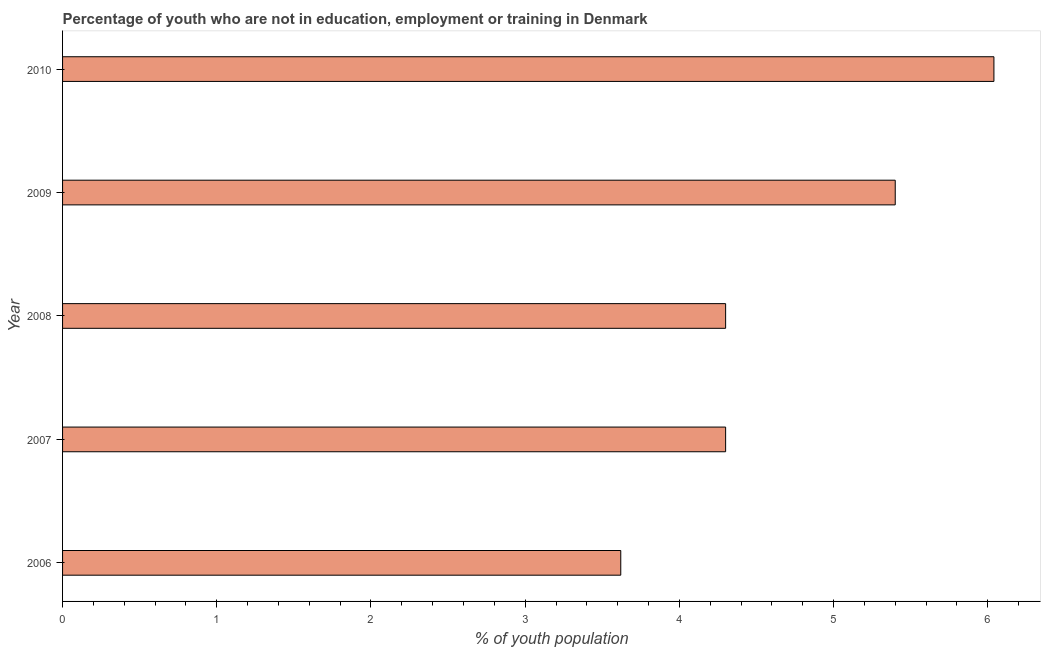Does the graph contain any zero values?
Make the answer very short. No. Does the graph contain grids?
Ensure brevity in your answer.  No. What is the title of the graph?
Provide a succinct answer. Percentage of youth who are not in education, employment or training in Denmark. What is the label or title of the X-axis?
Provide a short and direct response. % of youth population. What is the unemployed youth population in 2007?
Your answer should be very brief. 4.3. Across all years, what is the maximum unemployed youth population?
Provide a succinct answer. 6.04. Across all years, what is the minimum unemployed youth population?
Your response must be concise. 3.62. What is the sum of the unemployed youth population?
Offer a terse response. 23.66. What is the difference between the unemployed youth population in 2006 and 2008?
Your response must be concise. -0.68. What is the average unemployed youth population per year?
Ensure brevity in your answer.  4.73. What is the median unemployed youth population?
Offer a very short reply. 4.3. In how many years, is the unemployed youth population greater than 0.4 %?
Your answer should be very brief. 5. Do a majority of the years between 2010 and 2007 (inclusive) have unemployed youth population greater than 4.6 %?
Offer a terse response. Yes. What is the ratio of the unemployed youth population in 2008 to that in 2009?
Your answer should be compact. 0.8. Is the unemployed youth population in 2006 less than that in 2010?
Give a very brief answer. Yes. Is the difference between the unemployed youth population in 2009 and 2010 greater than the difference between any two years?
Offer a terse response. No. What is the difference between the highest and the second highest unemployed youth population?
Give a very brief answer. 0.64. Is the sum of the unemployed youth population in 2008 and 2010 greater than the maximum unemployed youth population across all years?
Your answer should be compact. Yes. What is the difference between the highest and the lowest unemployed youth population?
Make the answer very short. 2.42. Are all the bars in the graph horizontal?
Your answer should be very brief. Yes. What is the difference between two consecutive major ticks on the X-axis?
Offer a terse response. 1. What is the % of youth population in 2006?
Give a very brief answer. 3.62. What is the % of youth population in 2007?
Keep it short and to the point. 4.3. What is the % of youth population in 2008?
Ensure brevity in your answer.  4.3. What is the % of youth population of 2009?
Offer a terse response. 5.4. What is the % of youth population in 2010?
Keep it short and to the point. 6.04. What is the difference between the % of youth population in 2006 and 2007?
Ensure brevity in your answer.  -0.68. What is the difference between the % of youth population in 2006 and 2008?
Offer a very short reply. -0.68. What is the difference between the % of youth population in 2006 and 2009?
Your answer should be very brief. -1.78. What is the difference between the % of youth population in 2006 and 2010?
Your answer should be compact. -2.42. What is the difference between the % of youth population in 2007 and 2010?
Your answer should be compact. -1.74. What is the difference between the % of youth population in 2008 and 2010?
Your response must be concise. -1.74. What is the difference between the % of youth population in 2009 and 2010?
Your answer should be compact. -0.64. What is the ratio of the % of youth population in 2006 to that in 2007?
Your answer should be compact. 0.84. What is the ratio of the % of youth population in 2006 to that in 2008?
Your response must be concise. 0.84. What is the ratio of the % of youth population in 2006 to that in 2009?
Your answer should be very brief. 0.67. What is the ratio of the % of youth population in 2006 to that in 2010?
Offer a terse response. 0.6. What is the ratio of the % of youth population in 2007 to that in 2008?
Keep it short and to the point. 1. What is the ratio of the % of youth population in 2007 to that in 2009?
Your answer should be compact. 0.8. What is the ratio of the % of youth population in 2007 to that in 2010?
Provide a short and direct response. 0.71. What is the ratio of the % of youth population in 2008 to that in 2009?
Keep it short and to the point. 0.8. What is the ratio of the % of youth population in 2008 to that in 2010?
Offer a very short reply. 0.71. What is the ratio of the % of youth population in 2009 to that in 2010?
Offer a very short reply. 0.89. 